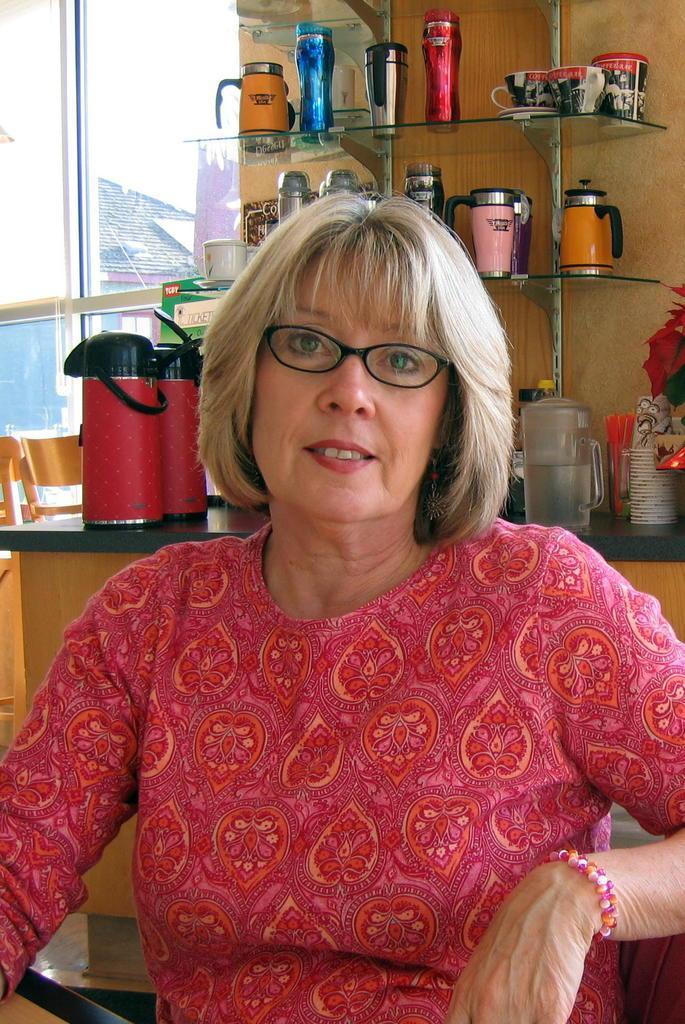Describe this image in one or two sentences. This picture shows a woman seated on the chair. She wore spectacles on their faces and we see few thermo flasks on the shelves and a jug of water and we see cups on the counter top and we see a window and couple of chairs and we see a building from the window. 